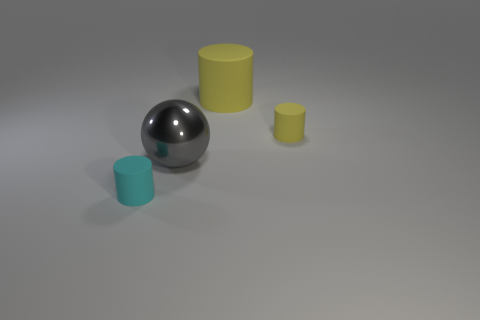Subtract all brown cylinders. Subtract all cyan cubes. How many cylinders are left? 3 Add 4 small purple balls. How many objects exist? 8 Subtract all cylinders. How many objects are left? 1 Add 4 small cyan cylinders. How many small cyan cylinders exist? 5 Subtract 0 green balls. How many objects are left? 4 Subtract all cyan matte cylinders. Subtract all big objects. How many objects are left? 1 Add 2 tiny cyan rubber things. How many tiny cyan rubber things are left? 3 